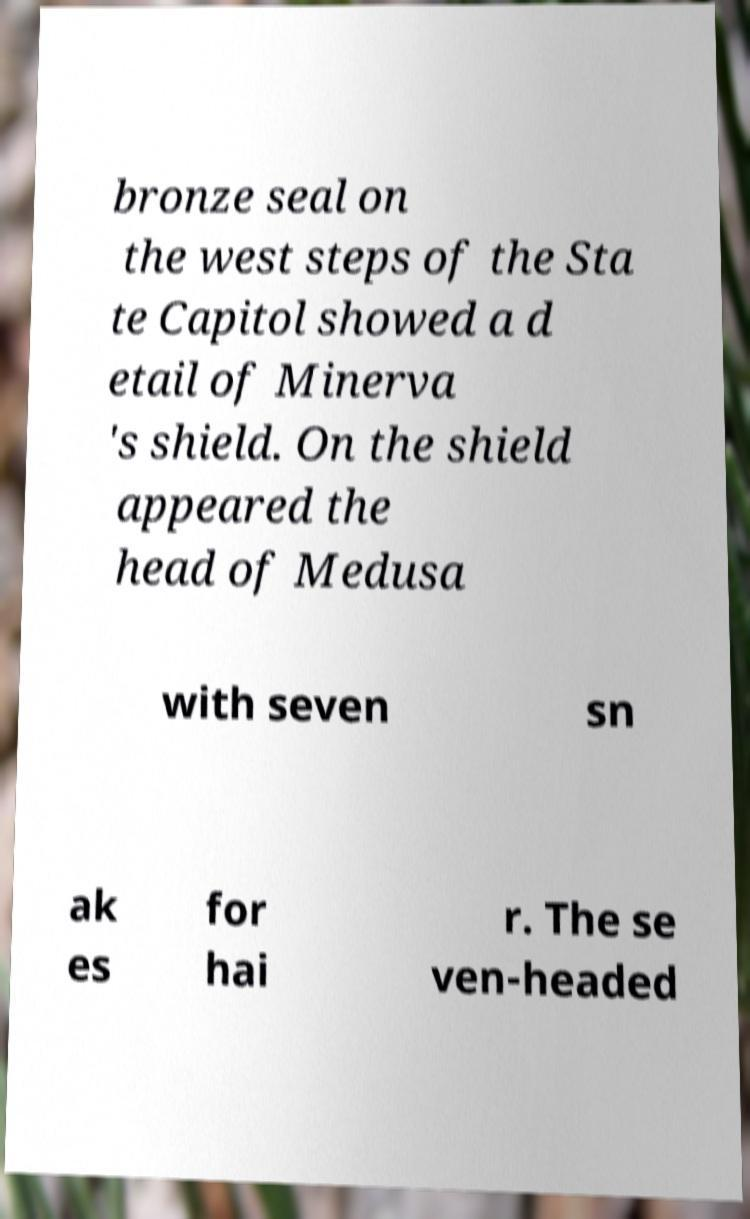Please identify and transcribe the text found in this image. bronze seal on the west steps of the Sta te Capitol showed a d etail of Minerva 's shield. On the shield appeared the head of Medusa with seven sn ak es for hai r. The se ven-headed 